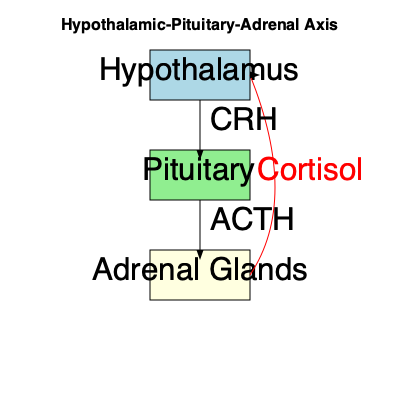In the hypothalamic-pituitary-adrenal (HPA) axis feedback loop, which hormone produced by the adrenal glands inhibits the release of CRH and ACTH, and what type of feedback mechanism does this represent? The hypothalamic-pituitary-adrenal (HPA) axis is a complex neuroendocrine system that regulates various physiological processes, including stress response. The feedback loop in this system works as follows:

1. The hypothalamus produces Corticotropin-Releasing Hormone (CRH).
2. CRH stimulates the anterior pituitary to release Adrenocorticotropic Hormone (ACTH).
3. ACTH then stimulates the adrenal glands to produce and release cortisol.
4. Cortisol, the main glucocorticoid in humans, has various effects on metabolism, immune function, and stress response.
5. Importantly, cortisol also acts back on the hypothalamus and pituitary gland to inhibit the further release of CRH and ACTH, respectively.

This inhibitory action of cortisol on CRH and ACTH release is a classic example of a negative feedback mechanism. Negative feedback is a regulatory mechanism where the output of a system inhibits its own production, helping to maintain homeostasis.

In this case, as cortisol levels rise, they signal the hypothalamus and pituitary to reduce CRH and ACTH production, respectively. This, in turn, leads to a decrease in cortisol production, preventing excessive levels of the hormone and maintaining balance in the system.
Answer: Cortisol; negative feedback 